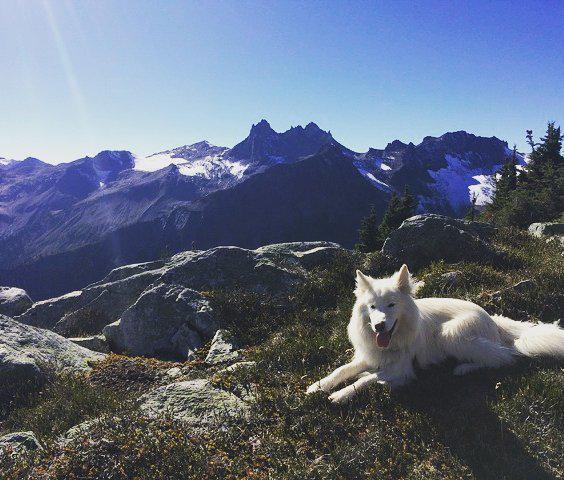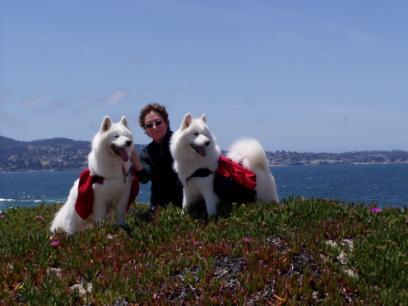The first image is the image on the left, the second image is the image on the right. Considering the images on both sides, is "Two white dogs wearing matching packs are side-by-side on an overlook, with hilly scenery in the background." valid? Answer yes or no. Yes. The first image is the image on the left, the second image is the image on the right. Considering the images on both sides, is "There are three dogs in the image pair." valid? Answer yes or no. Yes. 